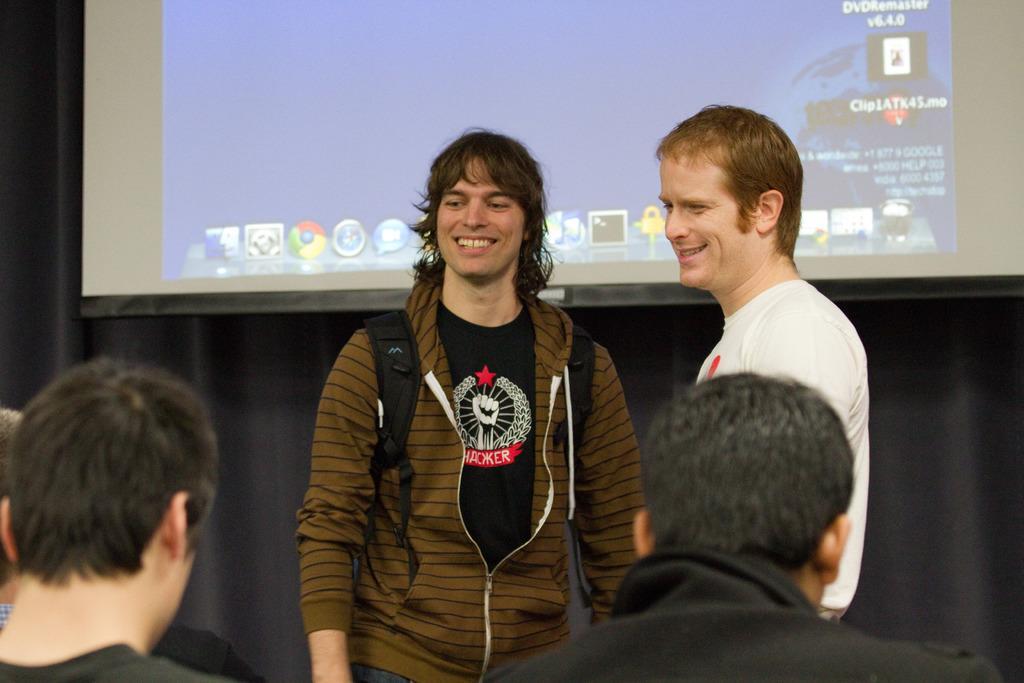Could you give a brief overview of what you see in this image? There are many people. Person in the center is wearing a jacket and a bag. In the background there is a screen and curtain. 